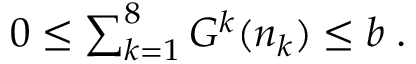Convert formula to latex. <formula><loc_0><loc_0><loc_500><loc_500>\begin{array} { r } { 0 \leq \sum _ { k = 1 } ^ { 8 } G ^ { k } ( n _ { k } ) \leq b \, . } \end{array}</formula> 